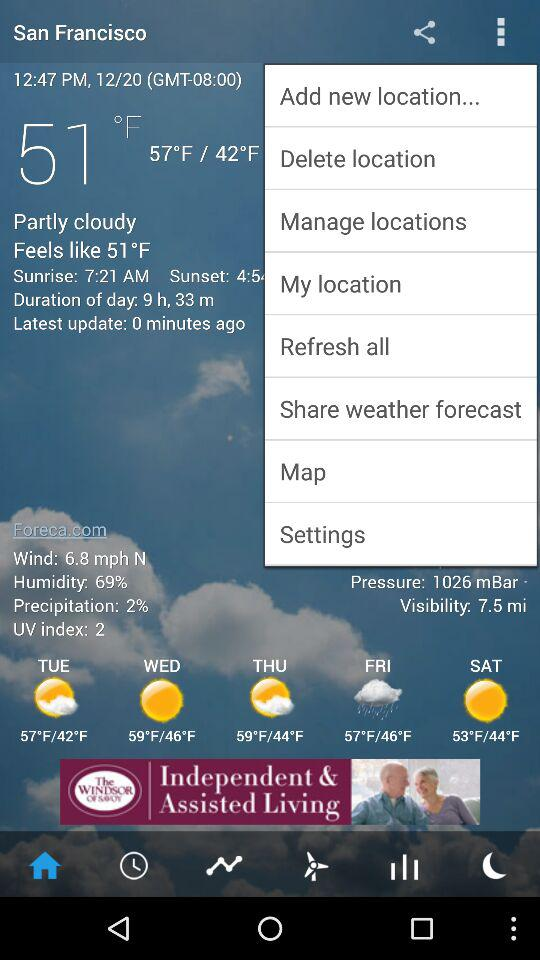What is the location? The location is San Francisco. 